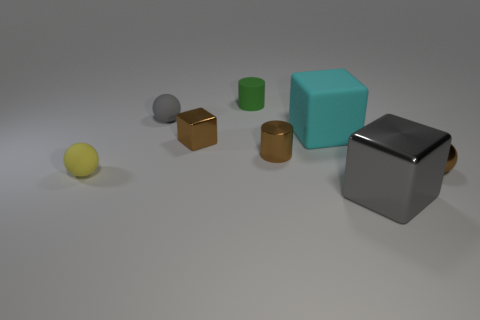There is a metal thing that is in front of the yellow ball that is on the left side of the cyan cube; what is its shape?
Your response must be concise. Cube. Are there any metal cylinders of the same size as the cyan cube?
Offer a very short reply. No. What number of small green matte objects have the same shape as the yellow matte thing?
Ensure brevity in your answer.  0. Are there an equal number of tiny green things that are in front of the cyan rubber cube and small balls in front of the tiny brown cube?
Make the answer very short. No. Are there any big cyan matte objects?
Provide a short and direct response. Yes. There is a brown metal thing that is to the right of the large thing in front of the small sphere on the right side of the tiny green matte thing; how big is it?
Provide a succinct answer. Small. There is a green thing that is the same size as the brown ball; what is its shape?
Give a very brief answer. Cylinder. What number of objects are either spheres that are in front of the brown shiny cube or purple objects?
Your answer should be compact. 2. Is there a gray shiny object right of the sphere right of the gray object to the right of the small gray rubber sphere?
Give a very brief answer. No. What number of large metal blocks are there?
Ensure brevity in your answer.  1. 